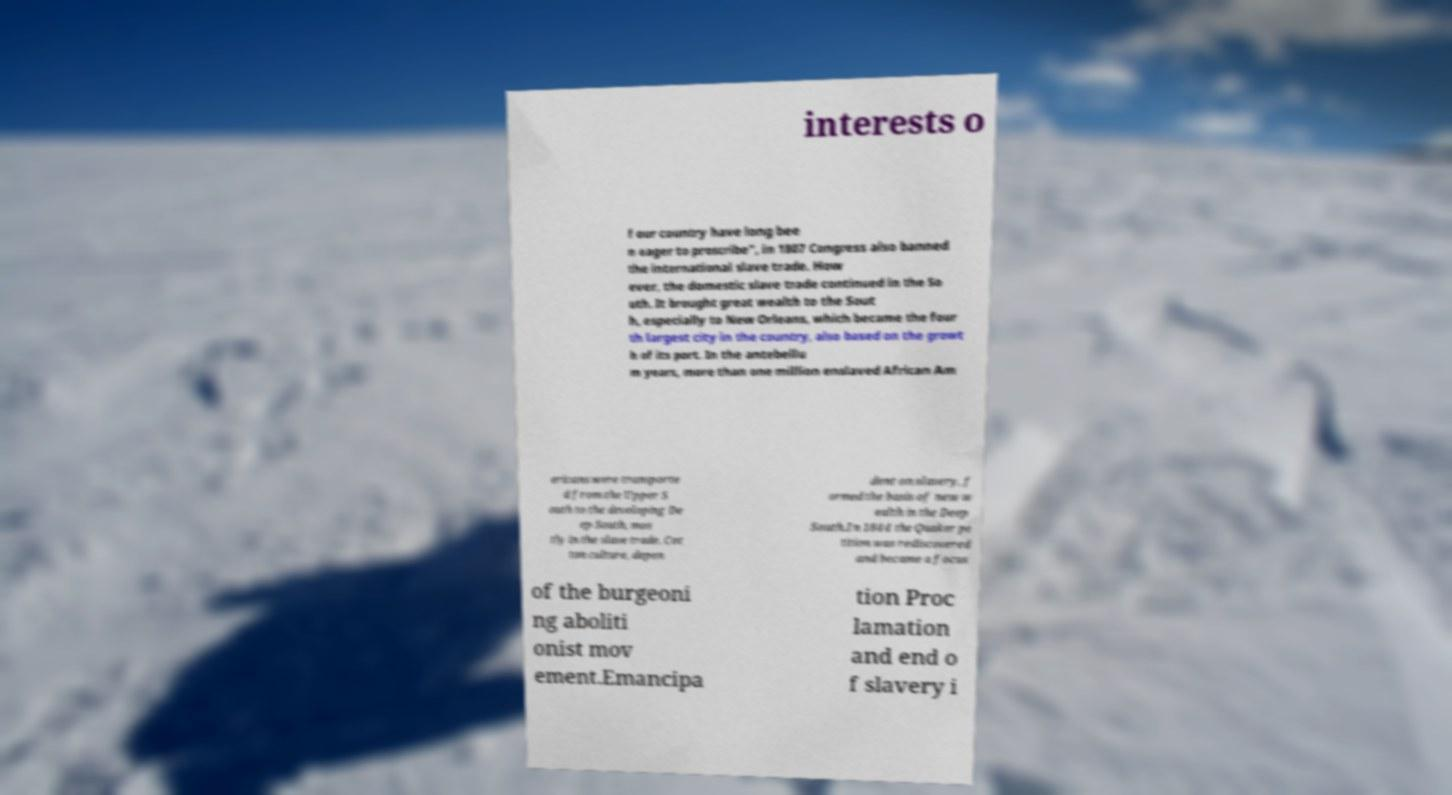For documentation purposes, I need the text within this image transcribed. Could you provide that? interests o f our country have long bee n eager to proscribe", in 1807 Congress also banned the international slave trade. How ever, the domestic slave trade continued in the So uth. It brought great wealth to the Sout h, especially to New Orleans, which became the four th largest city in the country, also based on the growt h of its port. In the antebellu m years, more than one million enslaved African Am ericans were transporte d from the Upper S outh to the developing De ep South, mos tly in the slave trade. Cot ton culture, depen dent on slavery, f ormed the basis of new w ealth in the Deep South.In 1844 the Quaker pe tition was rediscovered and became a focus of the burgeoni ng aboliti onist mov ement.Emancipa tion Proc lamation and end o f slavery i 